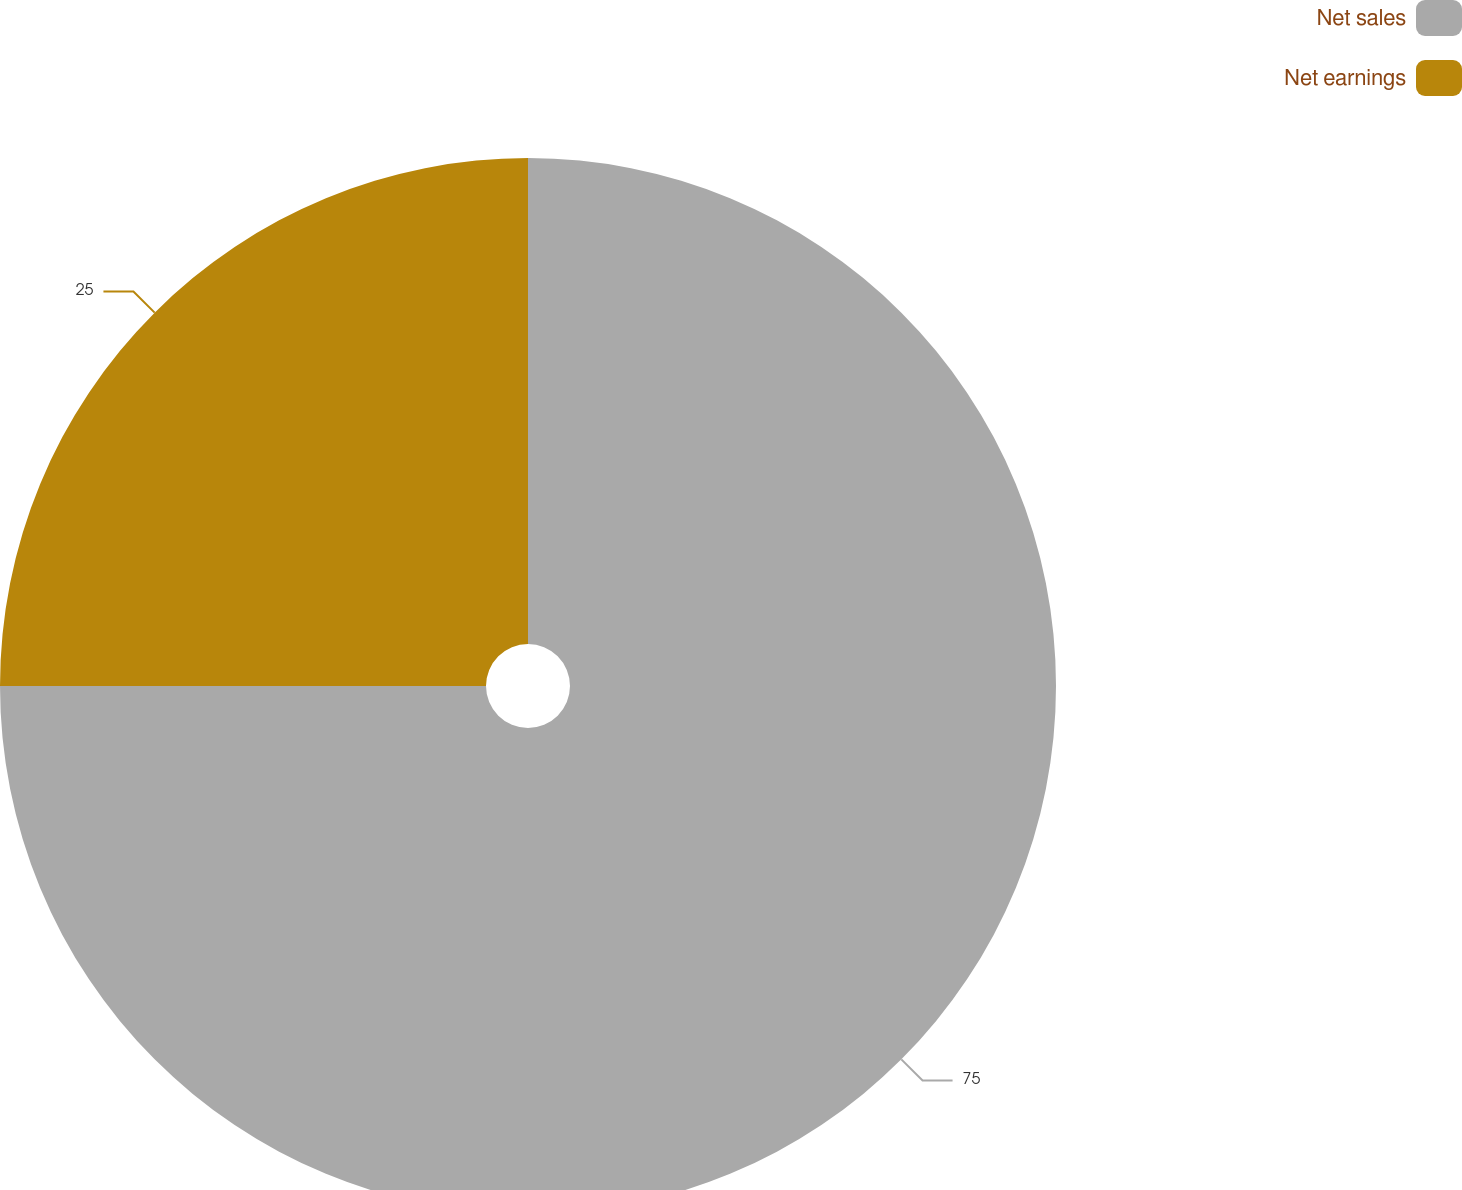Convert chart to OTSL. <chart><loc_0><loc_0><loc_500><loc_500><pie_chart><fcel>Net sales<fcel>Net earnings<nl><fcel>75.0%<fcel>25.0%<nl></chart> 